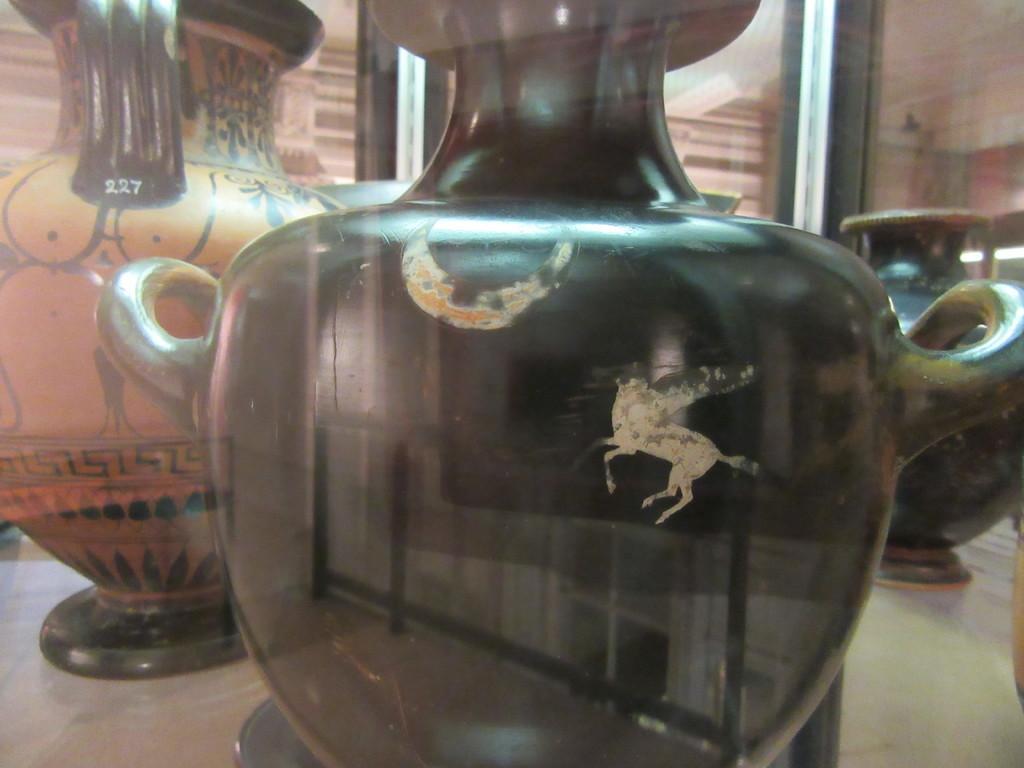How would you summarize this image in a sentence or two? In the image we can see flower vases on the surface. 